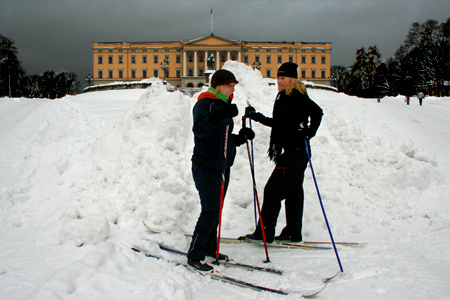Who wears pants? The girl is wearing pants. 